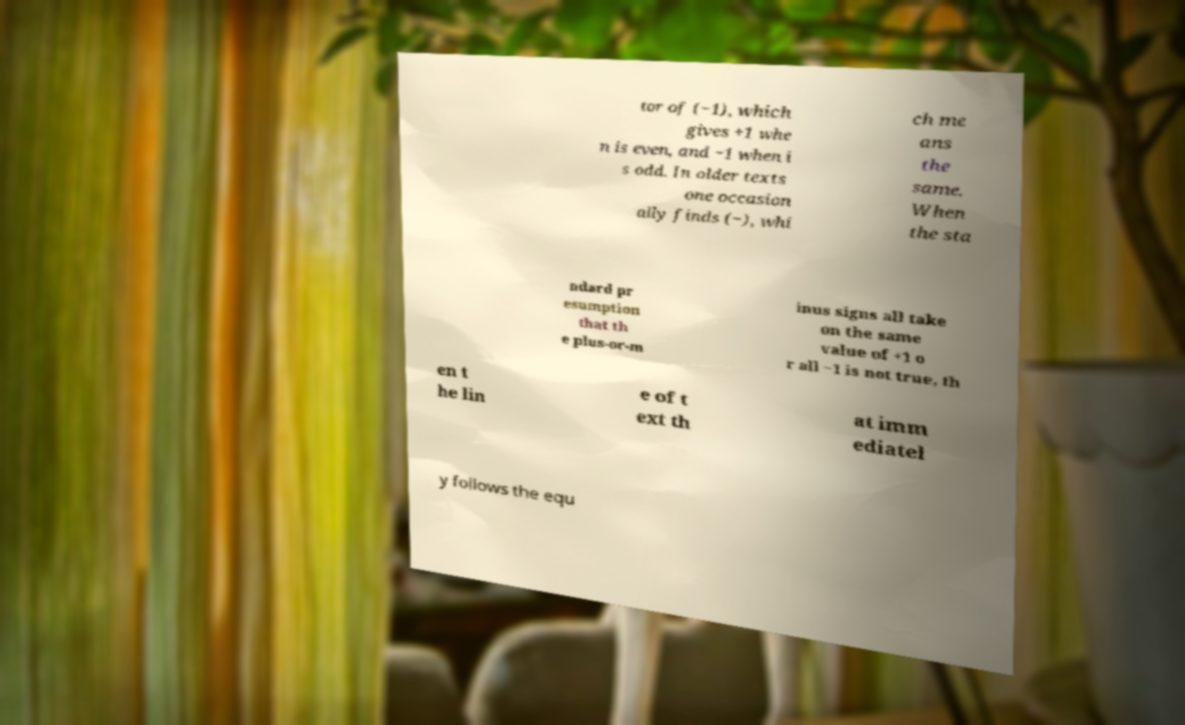There's text embedded in this image that I need extracted. Can you transcribe it verbatim? tor of (−1), which gives +1 whe n is even, and −1 when i s odd. In older texts one occasion ally finds (−), whi ch me ans the same. When the sta ndard pr esumption that th e plus-or-m inus signs all take on the same value of +1 o r all −1 is not true, th en t he lin e of t ext th at imm ediatel y follows the equ 